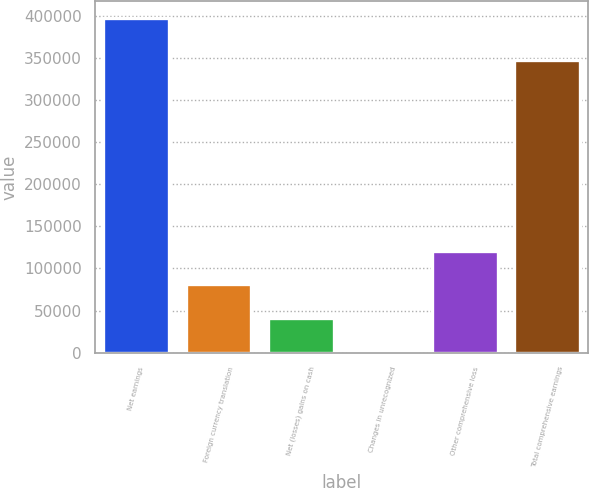<chart> <loc_0><loc_0><loc_500><loc_500><bar_chart><fcel>Net earnings<fcel>Foreign currency translation<fcel>Net (losses) gains on cash<fcel>Changes in unrecognized<fcel>Other comprehensive loss<fcel>Total comprehensive earnings<nl><fcel>397752<fcel>81000<fcel>41406<fcel>1812<fcel>120594<fcel>347270<nl></chart> 